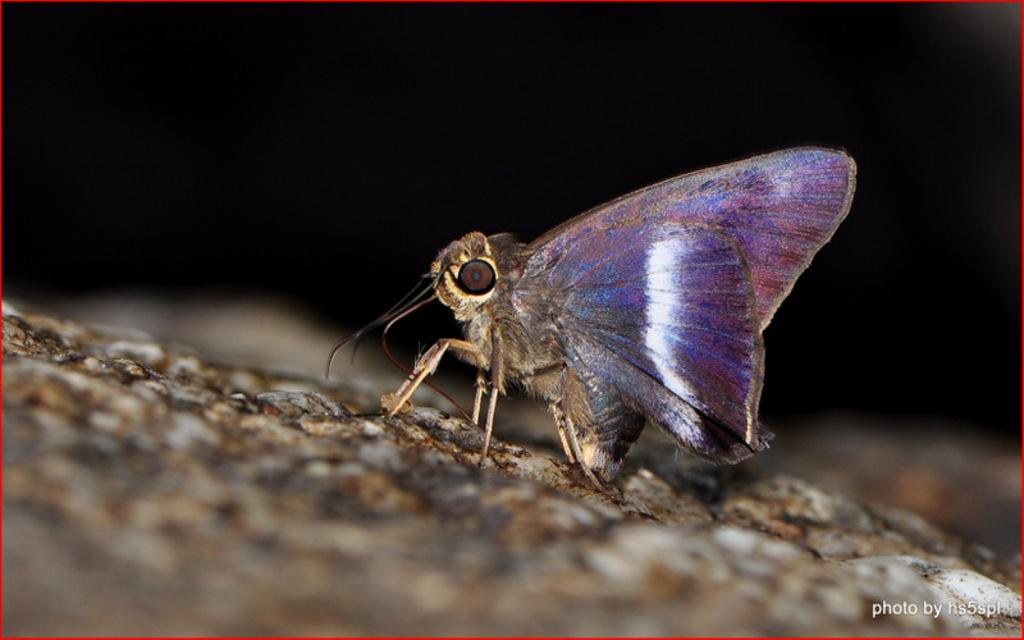What is present in the image that is not a part of the text or border? There is a fly in the image. Where can the text be found in the image? The text is located at the right bottom of the image. What color is the border surrounding the image? The border is red in color. What type of floor can be seen in the image? There is no floor visible in the image; it only contains a fly, text, and a red border. Is there an arch present in the image? There is no arch present in the image. 